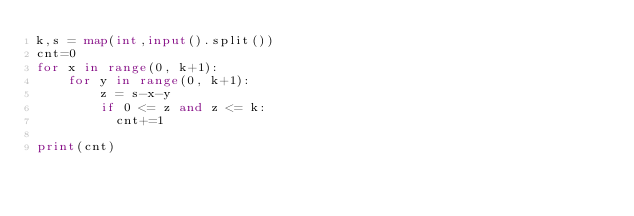Convert code to text. <code><loc_0><loc_0><loc_500><loc_500><_Python_>k,s = map(int,input().split())
cnt=0
for x in range(0, k+1):
    for y in range(0, k+1):
        z = s-x-y
        if 0 <= z and z <= k:
          cnt+=1
            
print(cnt)</code> 